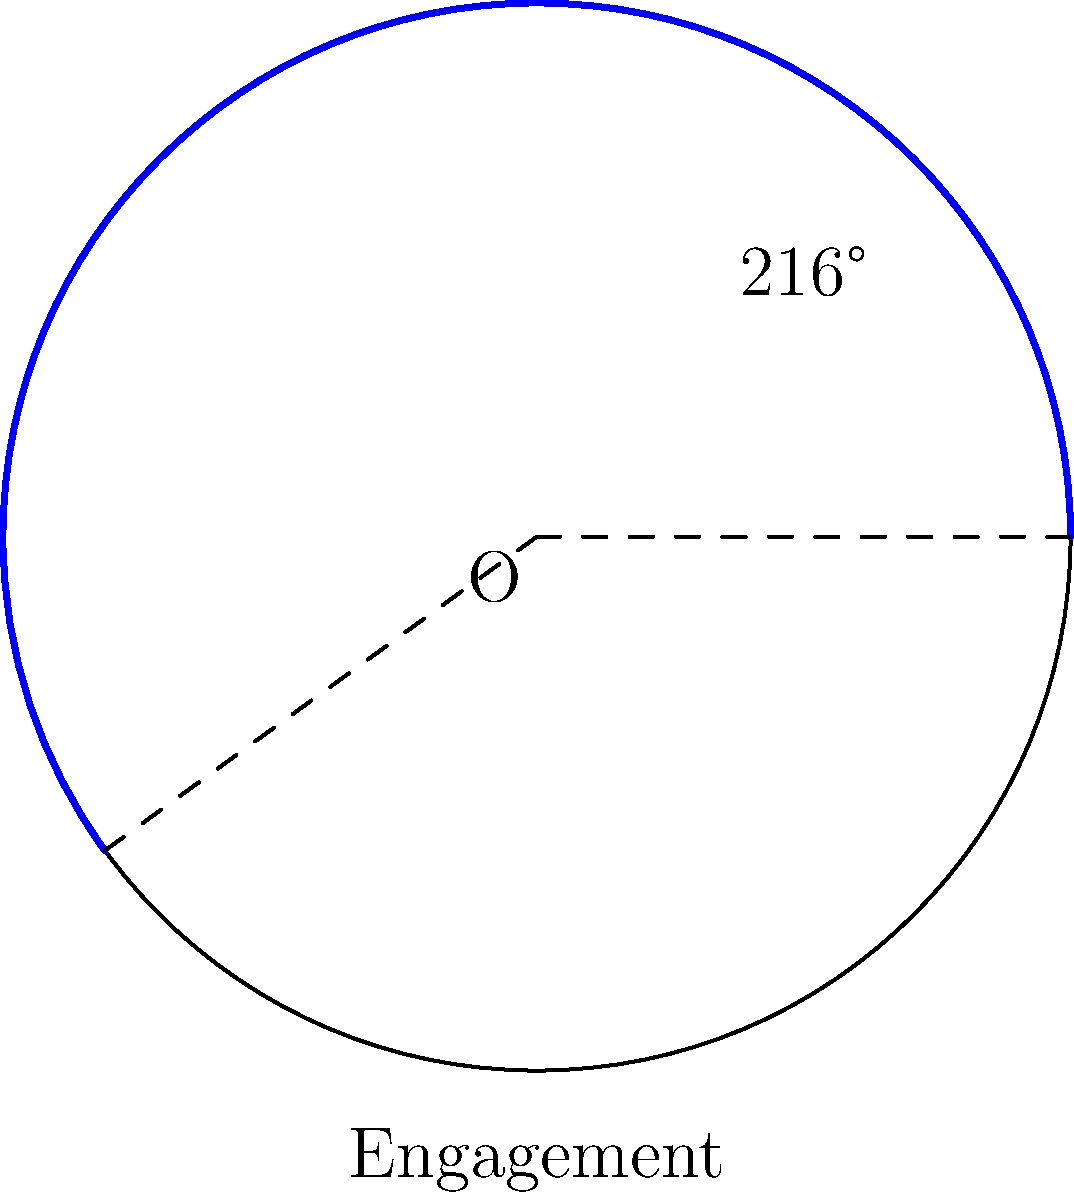On a circular progress chart representing user engagement for a social media campaign, an arc spans 216°. If the chart has a radius of 15 cm, what is the length of the arc representing the engagement metric? To find the length of the arc, we'll follow these steps:

1) Recall the formula for arc length: $s = r\theta$
   Where $s$ is the arc length, $r$ is the radius, and $\theta$ is the angle in radians.

2) We're given the angle in degrees (216°), but we need it in radians. 
   To convert, use the formula: $\theta_{radians} = \theta_{degrees} \times \frac{\pi}{180°}$

3) Calculate $\theta$ in radians:
   $\theta = 216° \times \frac{\pi}{180°} = 3.7699 \text{ radians}$

4) Now we can use the arc length formula:
   $s = r\theta$
   $s = 15 \text{ cm} \times 3.7699 \text{ radians}$
   $s = 56.5485 \text{ cm}$

5) Rounding to two decimal places:
   $s \approx 56.55 \text{ cm}$

Therefore, the length of the arc representing the engagement metric is approximately 56.55 cm.
Answer: 56.55 cm 